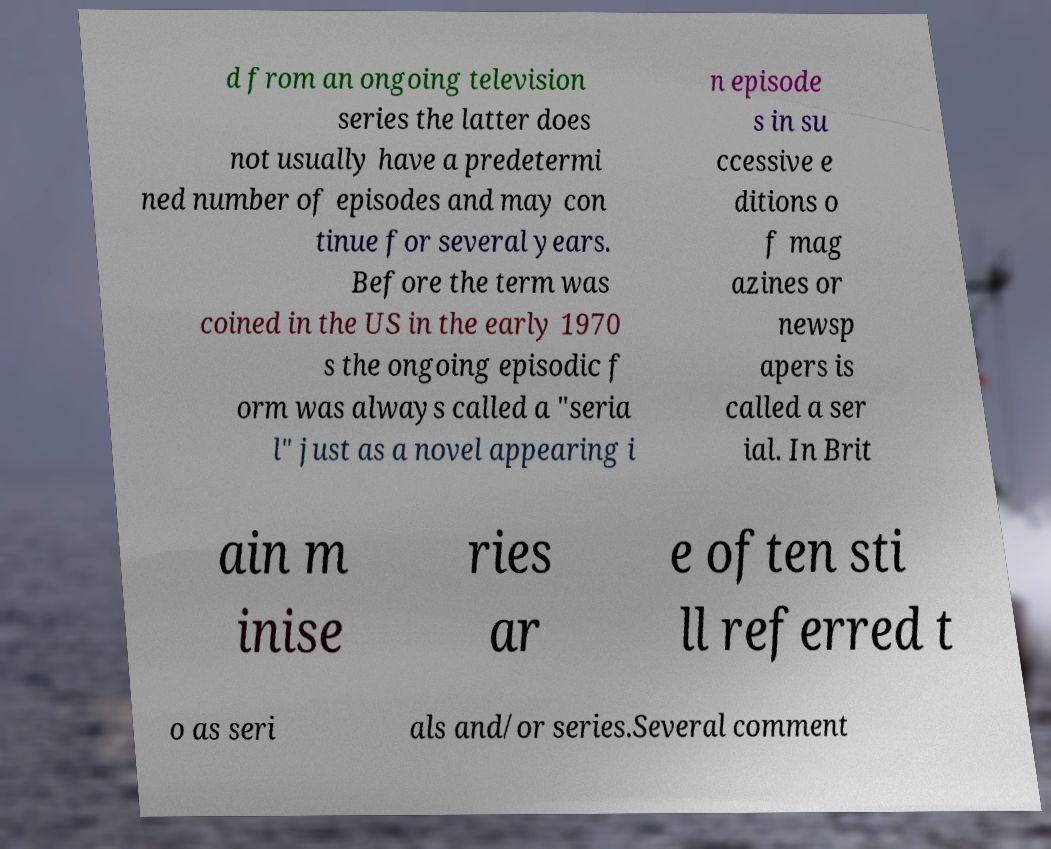Can you accurately transcribe the text from the provided image for me? d from an ongoing television series the latter does not usually have a predetermi ned number of episodes and may con tinue for several years. Before the term was coined in the US in the early 1970 s the ongoing episodic f orm was always called a "seria l" just as a novel appearing i n episode s in su ccessive e ditions o f mag azines or newsp apers is called a ser ial. In Brit ain m inise ries ar e often sti ll referred t o as seri als and/or series.Several comment 